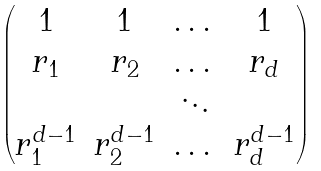<formula> <loc_0><loc_0><loc_500><loc_500>\begin{pmatrix} 1 & 1 & \dots & 1 \\ r _ { 1 } & r _ { 2 } & \dots & r _ { d } \\ & & \ddots & \\ r _ { 1 } ^ { d - 1 } & r _ { 2 } ^ { d - 1 } & \dots & r _ { d } ^ { d - 1 } \end{pmatrix}</formula> 